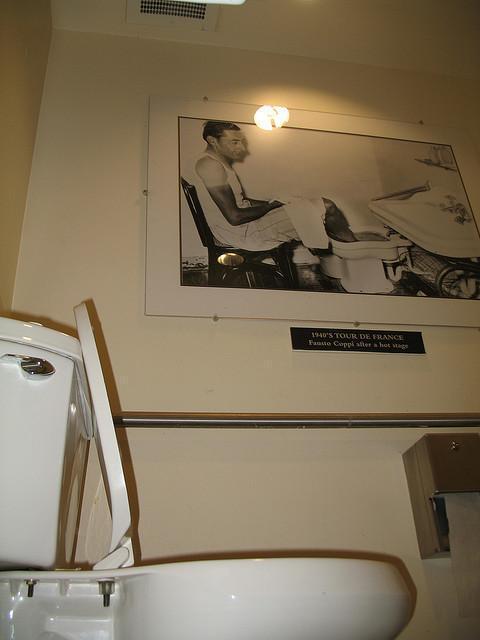How many pizzas are in the photo?
Give a very brief answer. 0. 